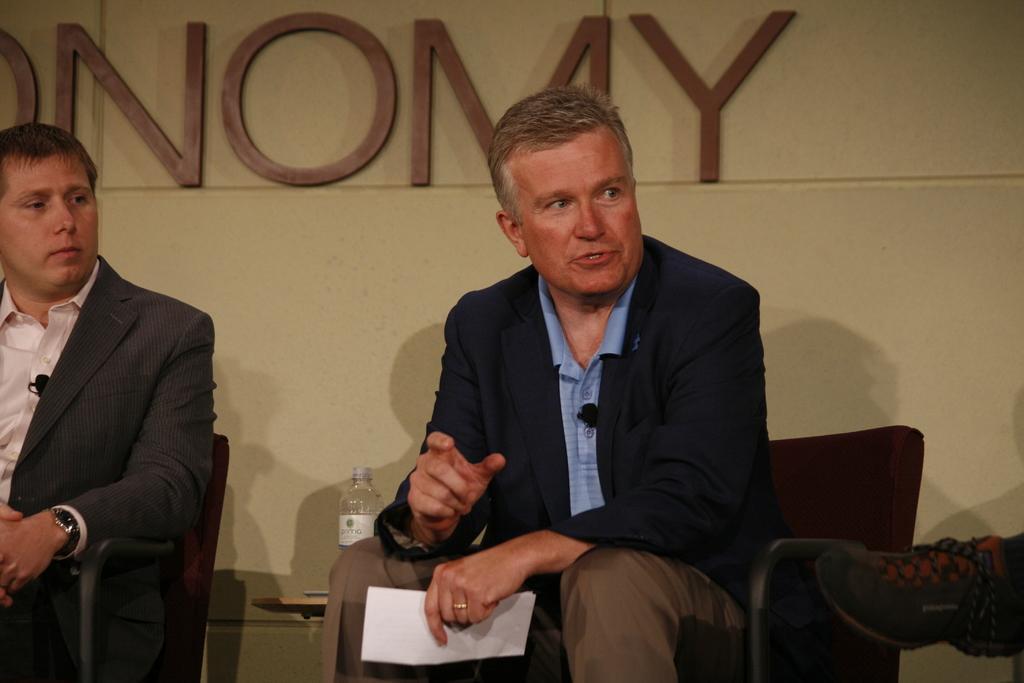Could you give a brief overview of what you see in this image? In this image I can see a man sitting on the chair,holding a paper and talking. At the left corner of the image I can see another person sitting on a chair. He is wearing suit and wrist watch. I can see a water bottle placed on a table. At the right corner of the image I can see a shoe. At background I can see letters which are attached to the wall. 